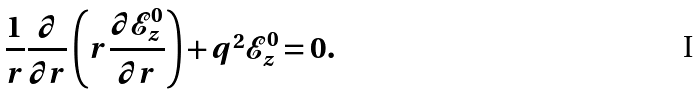<formula> <loc_0><loc_0><loc_500><loc_500>\frac { 1 } { r } \frac { \partial } { \partial r } \left ( r \frac { \partial \mathcal { E } _ { z } ^ { 0 } } { \partial r } \right ) + q ^ { 2 } \mathcal { E } _ { z } ^ { 0 } = 0 .</formula> 